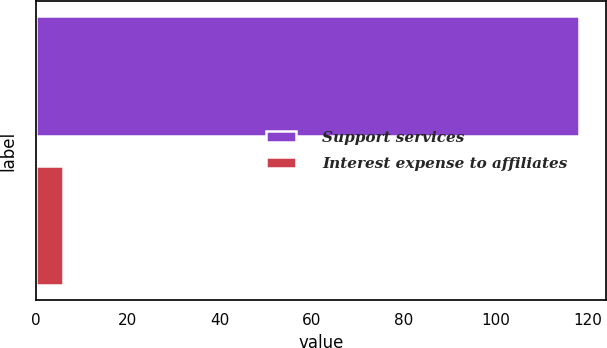<chart> <loc_0><loc_0><loc_500><loc_500><bar_chart><fcel>Support services<fcel>Interest expense to affiliates<nl><fcel>118<fcel>6<nl></chart> 